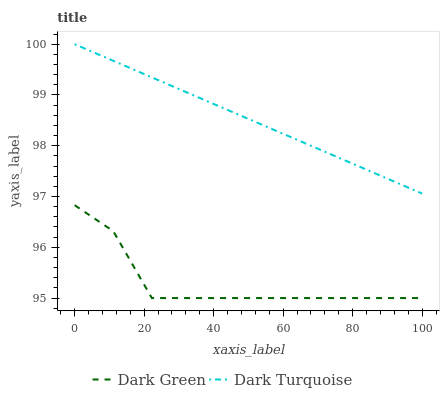Does Dark Green have the maximum area under the curve?
Answer yes or no. No. Is Dark Green the smoothest?
Answer yes or no. No. Does Dark Green have the highest value?
Answer yes or no. No. Is Dark Green less than Dark Turquoise?
Answer yes or no. Yes. Is Dark Turquoise greater than Dark Green?
Answer yes or no. Yes. Does Dark Green intersect Dark Turquoise?
Answer yes or no. No. 